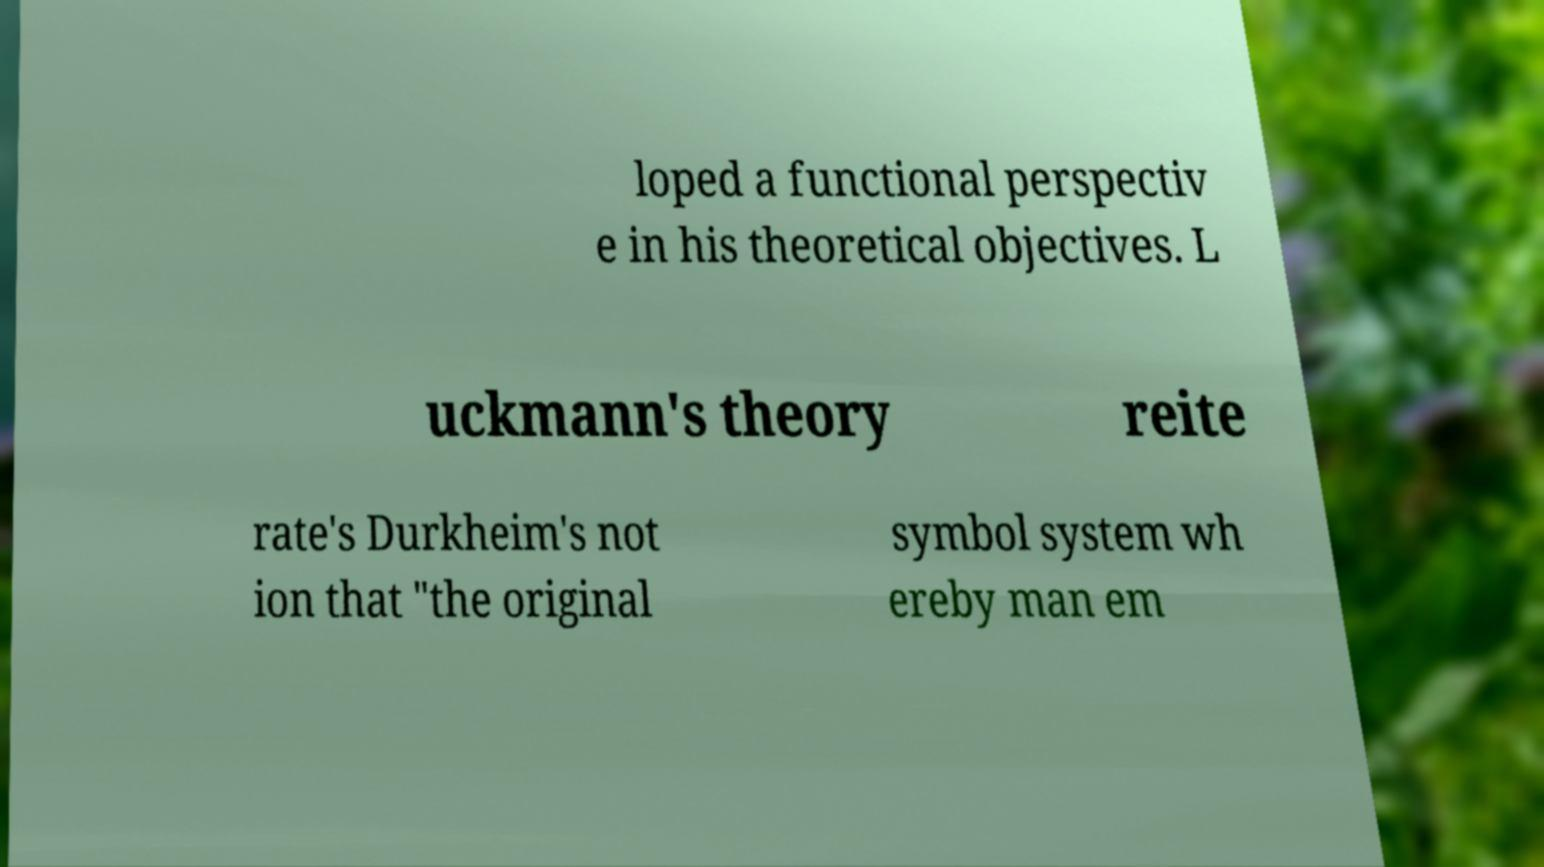Please identify and transcribe the text found in this image. loped a functional perspectiv e in his theoretical objectives. L uckmann's theory reite rate's Durkheim's not ion that "the original symbol system wh ereby man em 